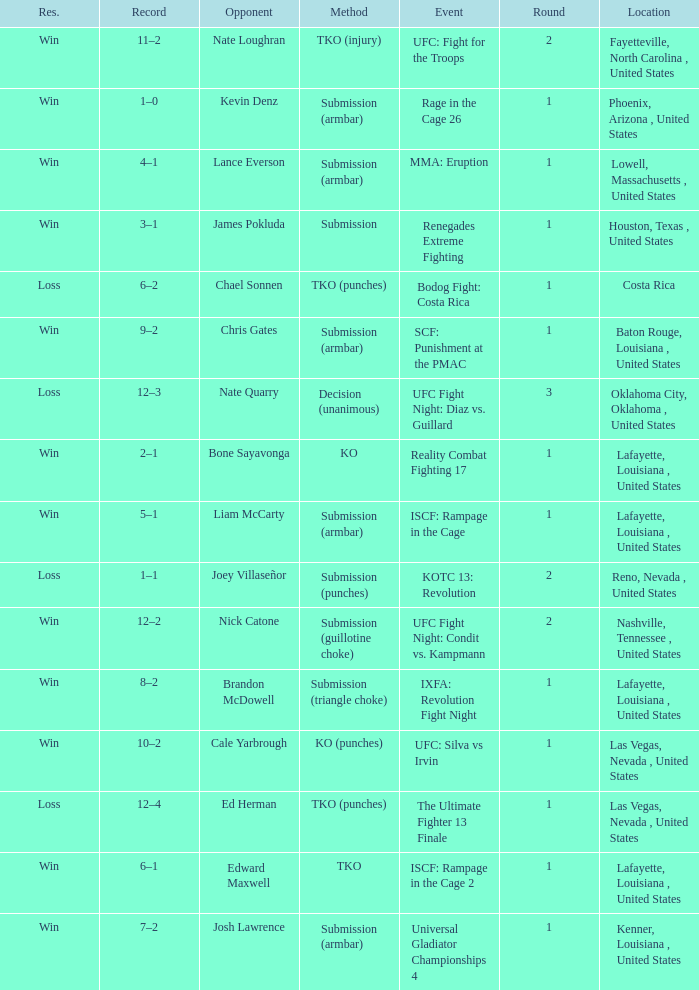What's was the location for fight against Liam Mccarty? Lafayette, Louisiana , United States. 